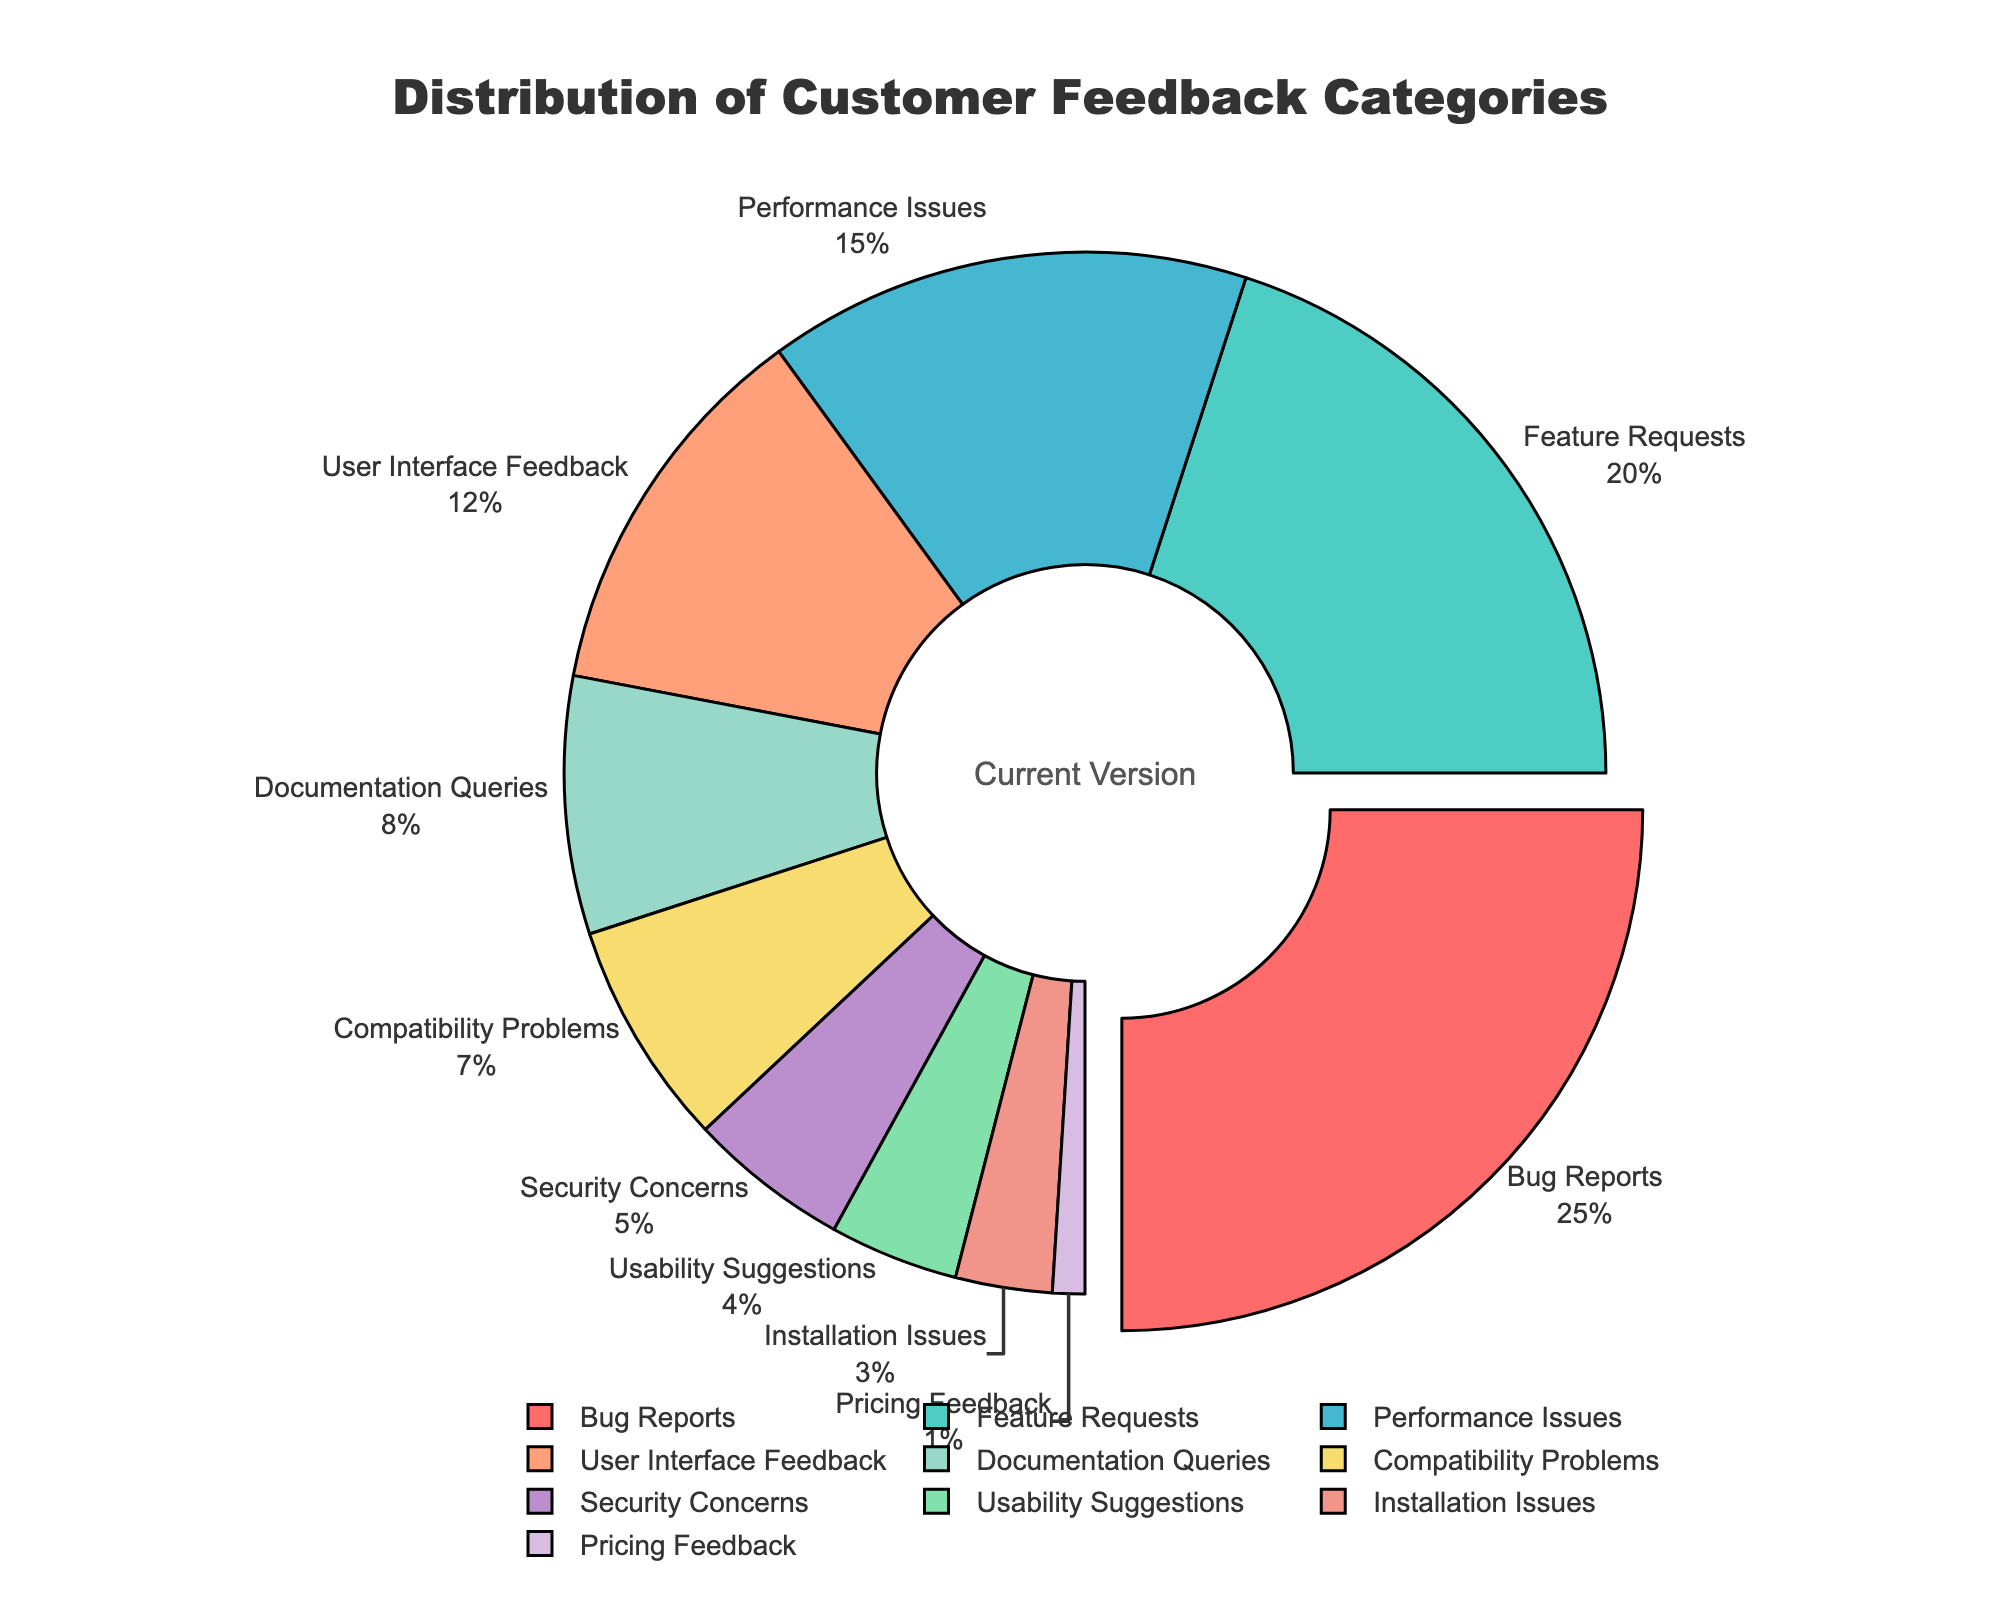What percentage of feedback is associated with User Interface Feedback? The figure shows each category along with its respective percentage. Locate "User Interface Feedback" and note the percentage value.
Answer: 12% Which category has the highest percentage of feedback? Observe the pie chart to identify which category occupies the largest portion of the chart.
Answer: Bug Reports What is the combined percentage of Feature Requests and Performance Issues? Find the percentage values for both "Feature Requests" and "Performance Issues" and add them together. Feature Requests is 20% and Performance Issues is 15%, so 20% + 15% = 35%.
Answer: 35% How does the percentage of Security Concerns compare to Installation Issues? Find the two categories on the pie chart and compare their percentages. Security Concerns is at 5% while Installation Issues is at 3%, so Security Concerns is higher.
Answer: Security Concerns is higher What color represents Bug Reports and Feature Requests? Locate each category on the pie chart and identify their colors. Bug Reports is represented by red and Feature Requests by green.
Answer: Red and green respectively What is the sum of the percentages for the top three categories? Identify the top three categories from the pie chart based on their percentages, add these percentages together. Bug Reports (25%), Feature Requests (20%), Performance Issues (15%). 25% + 20% + 15% = 60%.
Answer: 60% Which category has the least percentage of feedback? Observe the pie chart and find the category with the smallest portion.
Answer: Pricing Feedback How much more percentage does Documentation Queries have compared to Usability Suggestions? Find the percentages for both categories and subtract the smaller one from the larger one. Documentation Queries is 8% and Usability Suggestions is 4%, so 8% - 4% = 4%.
Answer: 4% What is the percentage difference between Bug Reports and Performance Issues? Find the percentage values for Bug Reports and Performance Issues, then subtract the smaller percentage from the larger one. Bug Reports is 25% and Performance Issues is 15%, so 25% - 15% = 10%.
Answer: 10% Is the percentage of User Interface Feedback more or less than double the Installation Issues? Compare the percentage value of User Interface Feedback (12%) directly with double the value of Installation Issues (3% * 2 = 6%). Since 12% is more than 6%, User Interface Feedback is more.
Answer: More 